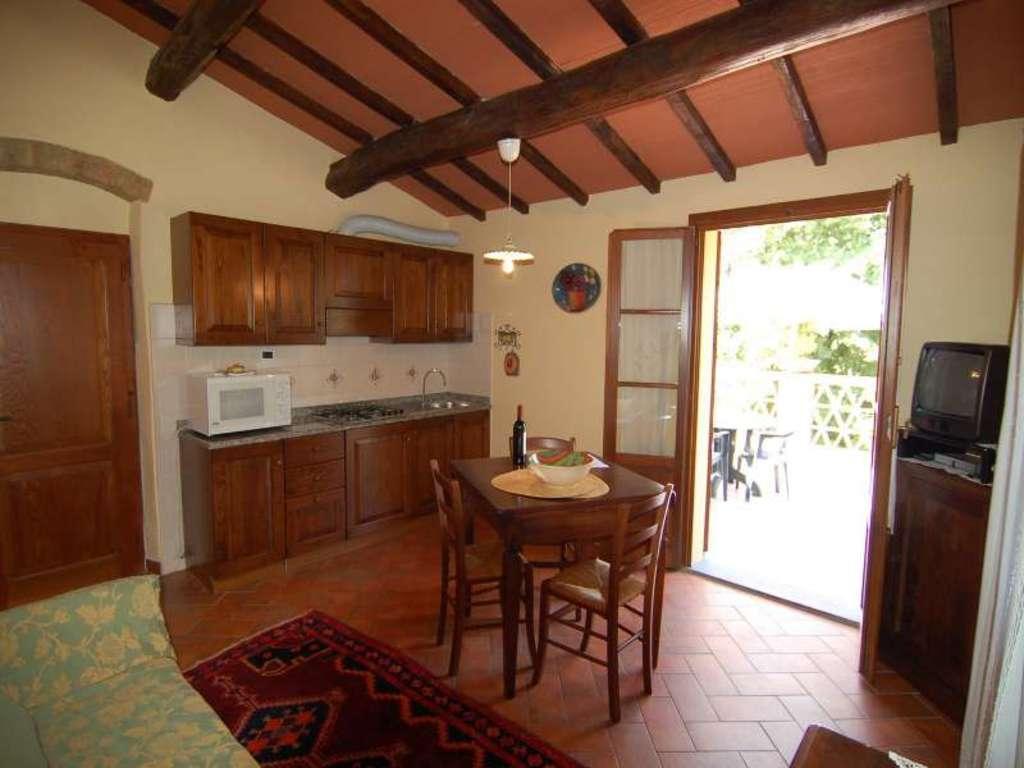How would you summarize this image in a sentence or two? This picture shows the inner view of a room. There are two wooden doors, one pipe attached to the wall, one light attached to the ceiling, one sofa, one pillow on the sofa, one dining table with chairs, some objects on the table, some cupboards, one gas stove, one micro oven, one tap with sink, some objects on the micro oven, some objects attached to the wall, one T. V on the table, one white curtain, one table with chairs in the balcony, one switchboard attached to the wall, one red carpet on the floor, some objects on the floor, one fence, some trees and one object on the balcony pillar. 